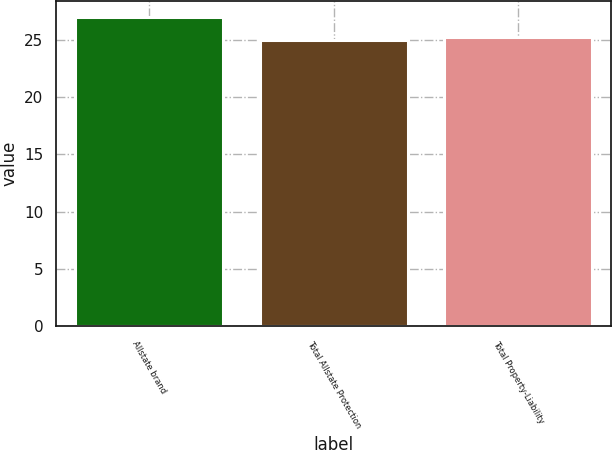Convert chart to OTSL. <chart><loc_0><loc_0><loc_500><loc_500><bar_chart><fcel>Allstate brand<fcel>Total Allstate Protection<fcel>Total Property-Liability<nl><fcel>27<fcel>25<fcel>25.2<nl></chart> 